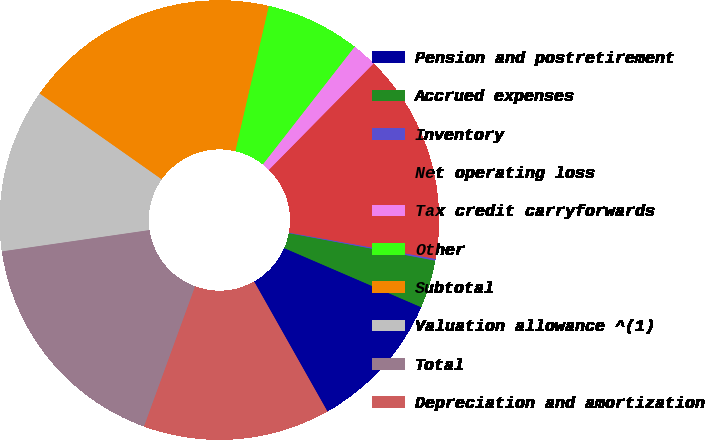Convert chart. <chart><loc_0><loc_0><loc_500><loc_500><pie_chart><fcel>Pension and postretirement<fcel>Accrued expenses<fcel>Inventory<fcel>Net operating loss<fcel>Tax credit carryforwards<fcel>Other<fcel>Subtotal<fcel>Valuation allowance ^(1)<fcel>Total<fcel>Depreciation and amortization<nl><fcel>10.34%<fcel>3.53%<fcel>0.13%<fcel>15.45%<fcel>1.83%<fcel>6.94%<fcel>18.85%<fcel>12.04%<fcel>17.15%<fcel>13.74%<nl></chart> 